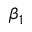Convert formula to latex. <formula><loc_0><loc_0><loc_500><loc_500>\beta _ { 1 }</formula> 